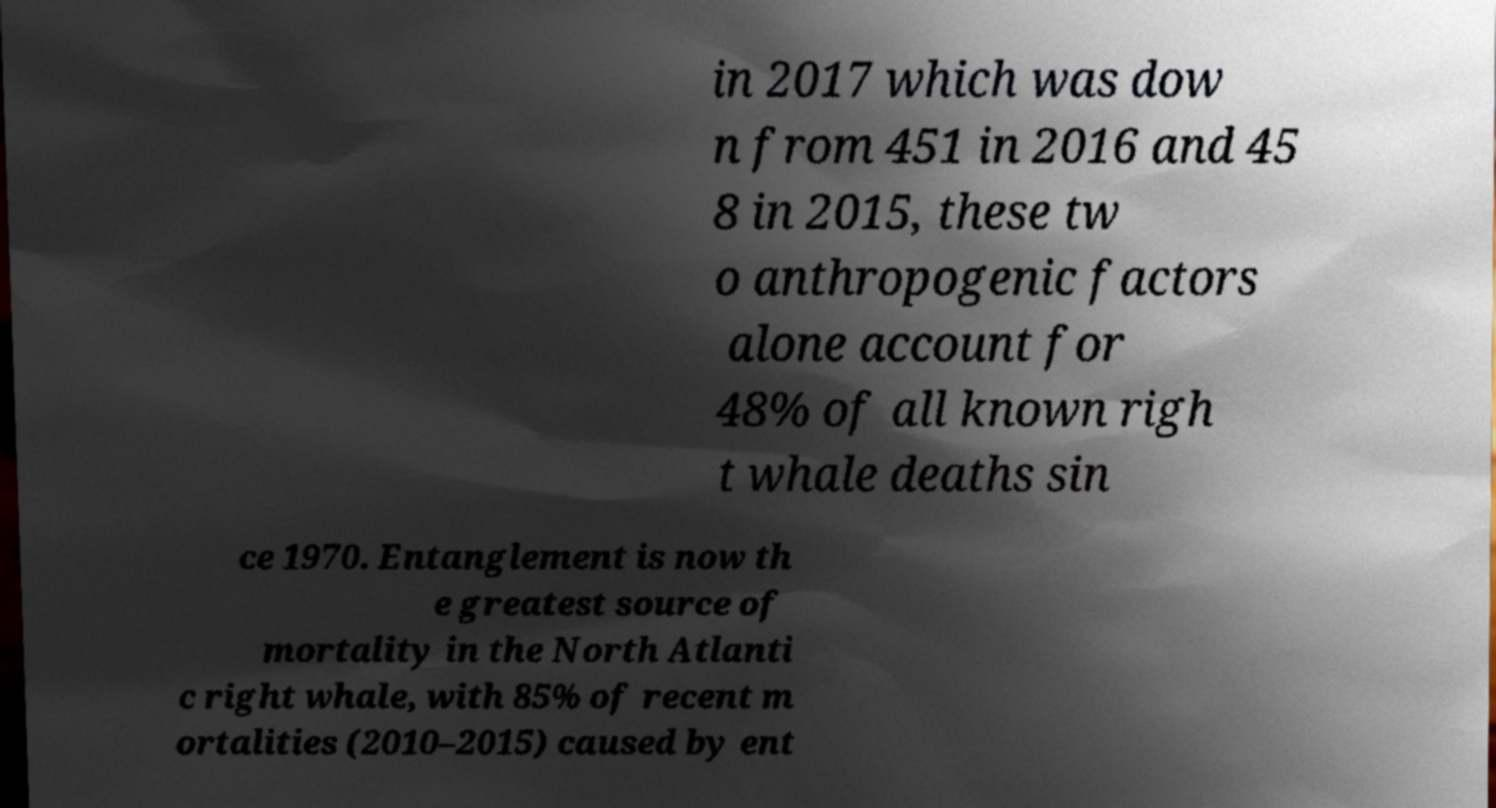What messages or text are displayed in this image? I need them in a readable, typed format. in 2017 which was dow n from 451 in 2016 and 45 8 in 2015, these tw o anthropogenic factors alone account for 48% of all known righ t whale deaths sin ce 1970. Entanglement is now th e greatest source of mortality in the North Atlanti c right whale, with 85% of recent m ortalities (2010–2015) caused by ent 